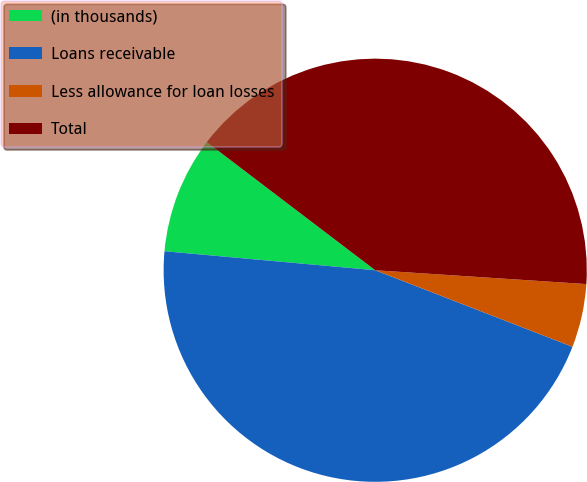Convert chart to OTSL. <chart><loc_0><loc_0><loc_500><loc_500><pie_chart><fcel>(in thousands)<fcel>Loans receivable<fcel>Less allowance for loan losses<fcel>Total<nl><fcel>8.92%<fcel>45.54%<fcel>4.85%<fcel>40.69%<nl></chart> 